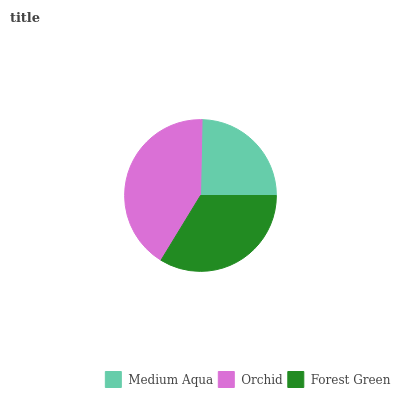Is Medium Aqua the minimum?
Answer yes or no. Yes. Is Orchid the maximum?
Answer yes or no. Yes. Is Forest Green the minimum?
Answer yes or no. No. Is Forest Green the maximum?
Answer yes or no. No. Is Orchid greater than Forest Green?
Answer yes or no. Yes. Is Forest Green less than Orchid?
Answer yes or no. Yes. Is Forest Green greater than Orchid?
Answer yes or no. No. Is Orchid less than Forest Green?
Answer yes or no. No. Is Forest Green the high median?
Answer yes or no. Yes. Is Forest Green the low median?
Answer yes or no. Yes. Is Orchid the high median?
Answer yes or no. No. Is Medium Aqua the low median?
Answer yes or no. No. 